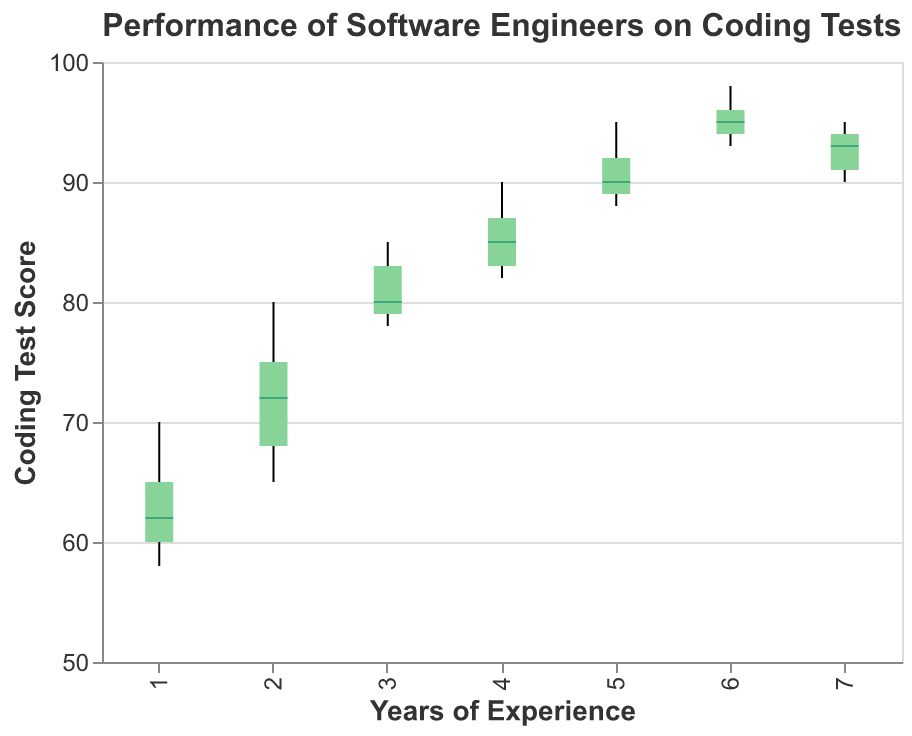What is the title of the figure? The title is usually displayed at the top of the figure. In this case, it's explicitly mentioned in the provided code.
Answer: Performance of Software Engineers on Coding Tests What is the range of Coding Test Scores for software engineers with 3 years of experience? In a box plot, the range is represented by the whiskers, which go from the minimum to the maximum values. For 3 years of experience, the minimum is 78 and the maximum is 85.
Answer: 78 to 85 What's the median Coding Test Score for engineers with 5 years of experience? The median value is represented by the line inside the box. For 5 years of experience, the median value, as per the given data, appears around 90.
Answer: 90 How does the interquartile range (IQR) of Coding Test Scores for 4 years of experience compare to that for 1 year of experience? The IQR is the range between the first quartile (Q1) and the third quartile (Q3). For 4 years of experience, the IQR spans from around 82 to 87, whereas for 1 year it ranges from around 60 to 65. 82-87 compared to 60-65 means the IQR for 4 years is larger.
Answer: The IQR for 4 years of experience is larger Which group has the highest variability in Coding Test Scores? Variability in a box plot is indicated by the length of the whiskers and the IQR (width of the box). The group with the largest spread (both in the box and whiskers) would have the highest variability. The group for engineers with 2 years of experience seems to have the widest spread.
Answer: Engineers with 2 years of experience Is there an upward trend in median Coding Test Scores with increasing years of experience? By examining the placement of median lines (dark horizontal lines within each box) from left (1 year) to right (7 years), we can observe that they progressively get higher, indicating an upward trend.
Answer: Yes What's the maximum Coding Test Score across all groups? The highest score appears at the top whisker of the group with 6 years of experience, which reaches 98.
Answer: 98 Which experience group has the lowest minimum score? The minimum score is represented by the bottom whisker of each box plot. The group with 1 year of experience has the lowest minimum score, at 58.
Answer: Engineers with 1 year of experience 